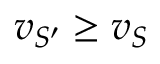<formula> <loc_0><loc_0><loc_500><loc_500>v _ { S ^ { \prime } } \geq v _ { S }</formula> 